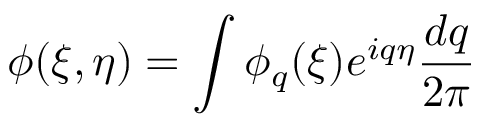<formula> <loc_0><loc_0><loc_500><loc_500>\phi ( \xi , \eta ) = \int \phi _ { q } ( \xi ) e ^ { i q \eta } \frac { d q } { 2 \pi }</formula> 